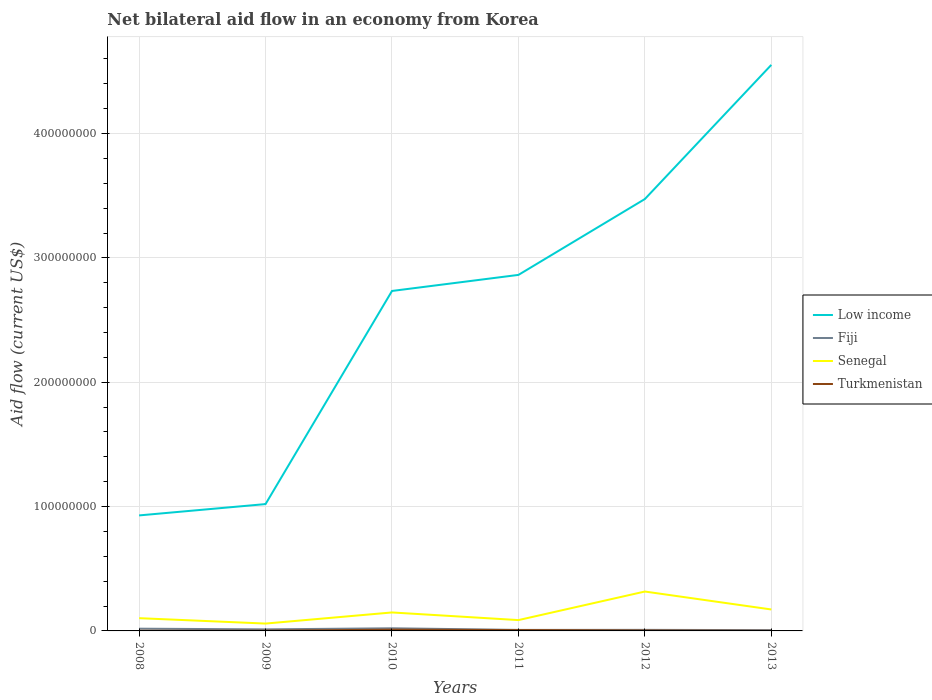How many different coloured lines are there?
Ensure brevity in your answer.  4. Is the number of lines equal to the number of legend labels?
Your answer should be very brief. Yes. Across all years, what is the maximum net bilateral aid flow in Senegal?
Ensure brevity in your answer.  5.92e+06. In which year was the net bilateral aid flow in Turkmenistan maximum?
Ensure brevity in your answer.  2008. What is the total net bilateral aid flow in Senegal in the graph?
Ensure brevity in your answer.  -2.79e+06. What is the difference between the highest and the second highest net bilateral aid flow in Fiji?
Give a very brief answer. 1.48e+06. How many lines are there?
Your response must be concise. 4. Are the values on the major ticks of Y-axis written in scientific E-notation?
Make the answer very short. No. Does the graph contain any zero values?
Make the answer very short. No. Does the graph contain grids?
Your answer should be compact. Yes. How are the legend labels stacked?
Provide a short and direct response. Vertical. What is the title of the graph?
Offer a very short reply. Net bilateral aid flow in an economy from Korea. What is the label or title of the Y-axis?
Offer a terse response. Aid flow (current US$). What is the Aid flow (current US$) in Low income in 2008?
Give a very brief answer. 9.29e+07. What is the Aid flow (current US$) of Fiji in 2008?
Keep it short and to the point. 1.80e+06. What is the Aid flow (current US$) of Senegal in 2008?
Your response must be concise. 1.02e+07. What is the Aid flow (current US$) of Low income in 2009?
Make the answer very short. 1.02e+08. What is the Aid flow (current US$) in Fiji in 2009?
Your answer should be very brief. 1.25e+06. What is the Aid flow (current US$) of Senegal in 2009?
Keep it short and to the point. 5.92e+06. What is the Aid flow (current US$) in Low income in 2010?
Your answer should be compact. 2.73e+08. What is the Aid flow (current US$) of Fiji in 2010?
Your response must be concise. 2.12e+06. What is the Aid flow (current US$) in Senegal in 2010?
Make the answer very short. 1.48e+07. What is the Aid flow (current US$) of Turkmenistan in 2010?
Provide a short and direct response. 1.01e+06. What is the Aid flow (current US$) in Low income in 2011?
Make the answer very short. 2.86e+08. What is the Aid flow (current US$) of Fiji in 2011?
Make the answer very short. 8.20e+05. What is the Aid flow (current US$) in Senegal in 2011?
Offer a terse response. 8.71e+06. What is the Aid flow (current US$) of Turkmenistan in 2011?
Offer a very short reply. 6.90e+05. What is the Aid flow (current US$) of Low income in 2012?
Ensure brevity in your answer.  3.47e+08. What is the Aid flow (current US$) of Fiji in 2012?
Offer a terse response. 8.60e+05. What is the Aid flow (current US$) of Senegal in 2012?
Provide a succinct answer. 3.17e+07. What is the Aid flow (current US$) of Low income in 2013?
Provide a succinct answer. 4.55e+08. What is the Aid flow (current US$) in Fiji in 2013?
Give a very brief answer. 6.40e+05. What is the Aid flow (current US$) of Senegal in 2013?
Give a very brief answer. 1.72e+07. Across all years, what is the maximum Aid flow (current US$) in Low income?
Provide a succinct answer. 4.55e+08. Across all years, what is the maximum Aid flow (current US$) in Fiji?
Offer a terse response. 2.12e+06. Across all years, what is the maximum Aid flow (current US$) in Senegal?
Offer a terse response. 3.17e+07. Across all years, what is the maximum Aid flow (current US$) of Turkmenistan?
Give a very brief answer. 1.01e+06. Across all years, what is the minimum Aid flow (current US$) of Low income?
Give a very brief answer. 9.29e+07. Across all years, what is the minimum Aid flow (current US$) in Fiji?
Provide a short and direct response. 6.40e+05. Across all years, what is the minimum Aid flow (current US$) of Senegal?
Offer a very short reply. 5.92e+06. What is the total Aid flow (current US$) in Low income in the graph?
Offer a terse response. 1.56e+09. What is the total Aid flow (current US$) in Fiji in the graph?
Provide a short and direct response. 7.49e+06. What is the total Aid flow (current US$) in Senegal in the graph?
Ensure brevity in your answer.  8.87e+07. What is the total Aid flow (current US$) of Turkmenistan in the graph?
Keep it short and to the point. 2.41e+06. What is the difference between the Aid flow (current US$) of Low income in 2008 and that in 2009?
Keep it short and to the point. -9.11e+06. What is the difference between the Aid flow (current US$) in Senegal in 2008 and that in 2009?
Keep it short and to the point. 4.33e+06. What is the difference between the Aid flow (current US$) of Turkmenistan in 2008 and that in 2009?
Make the answer very short. -6.00e+04. What is the difference between the Aid flow (current US$) in Low income in 2008 and that in 2010?
Ensure brevity in your answer.  -1.81e+08. What is the difference between the Aid flow (current US$) of Fiji in 2008 and that in 2010?
Offer a very short reply. -3.20e+05. What is the difference between the Aid flow (current US$) of Senegal in 2008 and that in 2010?
Provide a succinct answer. -4.60e+06. What is the difference between the Aid flow (current US$) in Turkmenistan in 2008 and that in 2010?
Offer a terse response. -9.00e+05. What is the difference between the Aid flow (current US$) of Low income in 2008 and that in 2011?
Give a very brief answer. -1.93e+08. What is the difference between the Aid flow (current US$) of Fiji in 2008 and that in 2011?
Offer a very short reply. 9.80e+05. What is the difference between the Aid flow (current US$) in Senegal in 2008 and that in 2011?
Provide a short and direct response. 1.54e+06. What is the difference between the Aid flow (current US$) in Turkmenistan in 2008 and that in 2011?
Offer a very short reply. -5.80e+05. What is the difference between the Aid flow (current US$) in Low income in 2008 and that in 2012?
Offer a very short reply. -2.54e+08. What is the difference between the Aid flow (current US$) of Fiji in 2008 and that in 2012?
Make the answer very short. 9.40e+05. What is the difference between the Aid flow (current US$) of Senegal in 2008 and that in 2012?
Provide a succinct answer. -2.14e+07. What is the difference between the Aid flow (current US$) of Turkmenistan in 2008 and that in 2012?
Your response must be concise. -2.10e+05. What is the difference between the Aid flow (current US$) in Low income in 2008 and that in 2013?
Your response must be concise. -3.62e+08. What is the difference between the Aid flow (current US$) in Fiji in 2008 and that in 2013?
Your answer should be very brief. 1.16e+06. What is the difference between the Aid flow (current US$) in Senegal in 2008 and that in 2013?
Your answer should be very brief. -7.00e+06. What is the difference between the Aid flow (current US$) in Turkmenistan in 2008 and that in 2013?
Offer a terse response. 0. What is the difference between the Aid flow (current US$) of Low income in 2009 and that in 2010?
Give a very brief answer. -1.71e+08. What is the difference between the Aid flow (current US$) in Fiji in 2009 and that in 2010?
Provide a succinct answer. -8.70e+05. What is the difference between the Aid flow (current US$) in Senegal in 2009 and that in 2010?
Provide a succinct answer. -8.93e+06. What is the difference between the Aid flow (current US$) of Turkmenistan in 2009 and that in 2010?
Your answer should be very brief. -8.40e+05. What is the difference between the Aid flow (current US$) of Low income in 2009 and that in 2011?
Offer a very short reply. -1.84e+08. What is the difference between the Aid flow (current US$) of Fiji in 2009 and that in 2011?
Give a very brief answer. 4.30e+05. What is the difference between the Aid flow (current US$) of Senegal in 2009 and that in 2011?
Make the answer very short. -2.79e+06. What is the difference between the Aid flow (current US$) of Turkmenistan in 2009 and that in 2011?
Give a very brief answer. -5.20e+05. What is the difference between the Aid flow (current US$) in Low income in 2009 and that in 2012?
Offer a very short reply. -2.45e+08. What is the difference between the Aid flow (current US$) of Senegal in 2009 and that in 2012?
Your answer should be compact. -2.58e+07. What is the difference between the Aid flow (current US$) of Low income in 2009 and that in 2013?
Your answer should be very brief. -3.53e+08. What is the difference between the Aid flow (current US$) in Fiji in 2009 and that in 2013?
Provide a succinct answer. 6.10e+05. What is the difference between the Aid flow (current US$) of Senegal in 2009 and that in 2013?
Your answer should be very brief. -1.13e+07. What is the difference between the Aid flow (current US$) of Turkmenistan in 2009 and that in 2013?
Give a very brief answer. 6.00e+04. What is the difference between the Aid flow (current US$) in Low income in 2010 and that in 2011?
Your answer should be very brief. -1.29e+07. What is the difference between the Aid flow (current US$) of Fiji in 2010 and that in 2011?
Your answer should be compact. 1.30e+06. What is the difference between the Aid flow (current US$) in Senegal in 2010 and that in 2011?
Your response must be concise. 6.14e+06. What is the difference between the Aid flow (current US$) of Turkmenistan in 2010 and that in 2011?
Make the answer very short. 3.20e+05. What is the difference between the Aid flow (current US$) in Low income in 2010 and that in 2012?
Offer a very short reply. -7.39e+07. What is the difference between the Aid flow (current US$) of Fiji in 2010 and that in 2012?
Provide a short and direct response. 1.26e+06. What is the difference between the Aid flow (current US$) in Senegal in 2010 and that in 2012?
Make the answer very short. -1.68e+07. What is the difference between the Aid flow (current US$) in Turkmenistan in 2010 and that in 2012?
Keep it short and to the point. 6.90e+05. What is the difference between the Aid flow (current US$) in Low income in 2010 and that in 2013?
Keep it short and to the point. -1.82e+08. What is the difference between the Aid flow (current US$) of Fiji in 2010 and that in 2013?
Keep it short and to the point. 1.48e+06. What is the difference between the Aid flow (current US$) in Senegal in 2010 and that in 2013?
Offer a very short reply. -2.40e+06. What is the difference between the Aid flow (current US$) in Low income in 2011 and that in 2012?
Make the answer very short. -6.10e+07. What is the difference between the Aid flow (current US$) of Senegal in 2011 and that in 2012?
Offer a very short reply. -2.30e+07. What is the difference between the Aid flow (current US$) of Turkmenistan in 2011 and that in 2012?
Your answer should be compact. 3.70e+05. What is the difference between the Aid flow (current US$) of Low income in 2011 and that in 2013?
Offer a very short reply. -1.69e+08. What is the difference between the Aid flow (current US$) in Fiji in 2011 and that in 2013?
Provide a succinct answer. 1.80e+05. What is the difference between the Aid flow (current US$) in Senegal in 2011 and that in 2013?
Your answer should be very brief. -8.54e+06. What is the difference between the Aid flow (current US$) in Turkmenistan in 2011 and that in 2013?
Offer a terse response. 5.80e+05. What is the difference between the Aid flow (current US$) of Low income in 2012 and that in 2013?
Keep it short and to the point. -1.08e+08. What is the difference between the Aid flow (current US$) in Fiji in 2012 and that in 2013?
Ensure brevity in your answer.  2.20e+05. What is the difference between the Aid flow (current US$) in Senegal in 2012 and that in 2013?
Offer a very short reply. 1.44e+07. What is the difference between the Aid flow (current US$) of Turkmenistan in 2012 and that in 2013?
Make the answer very short. 2.10e+05. What is the difference between the Aid flow (current US$) of Low income in 2008 and the Aid flow (current US$) of Fiji in 2009?
Provide a short and direct response. 9.16e+07. What is the difference between the Aid flow (current US$) in Low income in 2008 and the Aid flow (current US$) in Senegal in 2009?
Offer a very short reply. 8.70e+07. What is the difference between the Aid flow (current US$) of Low income in 2008 and the Aid flow (current US$) of Turkmenistan in 2009?
Offer a very short reply. 9.27e+07. What is the difference between the Aid flow (current US$) of Fiji in 2008 and the Aid flow (current US$) of Senegal in 2009?
Keep it short and to the point. -4.12e+06. What is the difference between the Aid flow (current US$) of Fiji in 2008 and the Aid flow (current US$) of Turkmenistan in 2009?
Your answer should be very brief. 1.63e+06. What is the difference between the Aid flow (current US$) in Senegal in 2008 and the Aid flow (current US$) in Turkmenistan in 2009?
Your response must be concise. 1.01e+07. What is the difference between the Aid flow (current US$) of Low income in 2008 and the Aid flow (current US$) of Fiji in 2010?
Provide a short and direct response. 9.08e+07. What is the difference between the Aid flow (current US$) of Low income in 2008 and the Aid flow (current US$) of Senegal in 2010?
Your response must be concise. 7.80e+07. What is the difference between the Aid flow (current US$) of Low income in 2008 and the Aid flow (current US$) of Turkmenistan in 2010?
Provide a succinct answer. 9.19e+07. What is the difference between the Aid flow (current US$) in Fiji in 2008 and the Aid flow (current US$) in Senegal in 2010?
Your response must be concise. -1.30e+07. What is the difference between the Aid flow (current US$) of Fiji in 2008 and the Aid flow (current US$) of Turkmenistan in 2010?
Keep it short and to the point. 7.90e+05. What is the difference between the Aid flow (current US$) in Senegal in 2008 and the Aid flow (current US$) in Turkmenistan in 2010?
Give a very brief answer. 9.24e+06. What is the difference between the Aid flow (current US$) in Low income in 2008 and the Aid flow (current US$) in Fiji in 2011?
Offer a very short reply. 9.21e+07. What is the difference between the Aid flow (current US$) in Low income in 2008 and the Aid flow (current US$) in Senegal in 2011?
Give a very brief answer. 8.42e+07. What is the difference between the Aid flow (current US$) in Low income in 2008 and the Aid flow (current US$) in Turkmenistan in 2011?
Provide a short and direct response. 9.22e+07. What is the difference between the Aid flow (current US$) in Fiji in 2008 and the Aid flow (current US$) in Senegal in 2011?
Your answer should be very brief. -6.91e+06. What is the difference between the Aid flow (current US$) of Fiji in 2008 and the Aid flow (current US$) of Turkmenistan in 2011?
Give a very brief answer. 1.11e+06. What is the difference between the Aid flow (current US$) in Senegal in 2008 and the Aid flow (current US$) in Turkmenistan in 2011?
Keep it short and to the point. 9.56e+06. What is the difference between the Aid flow (current US$) in Low income in 2008 and the Aid flow (current US$) in Fiji in 2012?
Provide a succinct answer. 9.20e+07. What is the difference between the Aid flow (current US$) of Low income in 2008 and the Aid flow (current US$) of Senegal in 2012?
Your answer should be very brief. 6.12e+07. What is the difference between the Aid flow (current US$) in Low income in 2008 and the Aid flow (current US$) in Turkmenistan in 2012?
Offer a very short reply. 9.26e+07. What is the difference between the Aid flow (current US$) of Fiji in 2008 and the Aid flow (current US$) of Senegal in 2012?
Your answer should be compact. -2.99e+07. What is the difference between the Aid flow (current US$) in Fiji in 2008 and the Aid flow (current US$) in Turkmenistan in 2012?
Give a very brief answer. 1.48e+06. What is the difference between the Aid flow (current US$) in Senegal in 2008 and the Aid flow (current US$) in Turkmenistan in 2012?
Ensure brevity in your answer.  9.93e+06. What is the difference between the Aid flow (current US$) of Low income in 2008 and the Aid flow (current US$) of Fiji in 2013?
Make the answer very short. 9.23e+07. What is the difference between the Aid flow (current US$) of Low income in 2008 and the Aid flow (current US$) of Senegal in 2013?
Keep it short and to the point. 7.56e+07. What is the difference between the Aid flow (current US$) of Low income in 2008 and the Aid flow (current US$) of Turkmenistan in 2013?
Your answer should be very brief. 9.28e+07. What is the difference between the Aid flow (current US$) in Fiji in 2008 and the Aid flow (current US$) in Senegal in 2013?
Offer a very short reply. -1.54e+07. What is the difference between the Aid flow (current US$) of Fiji in 2008 and the Aid flow (current US$) of Turkmenistan in 2013?
Provide a succinct answer. 1.69e+06. What is the difference between the Aid flow (current US$) of Senegal in 2008 and the Aid flow (current US$) of Turkmenistan in 2013?
Provide a succinct answer. 1.01e+07. What is the difference between the Aid flow (current US$) of Low income in 2009 and the Aid flow (current US$) of Fiji in 2010?
Ensure brevity in your answer.  9.99e+07. What is the difference between the Aid flow (current US$) of Low income in 2009 and the Aid flow (current US$) of Senegal in 2010?
Provide a succinct answer. 8.72e+07. What is the difference between the Aid flow (current US$) in Low income in 2009 and the Aid flow (current US$) in Turkmenistan in 2010?
Ensure brevity in your answer.  1.01e+08. What is the difference between the Aid flow (current US$) of Fiji in 2009 and the Aid flow (current US$) of Senegal in 2010?
Your response must be concise. -1.36e+07. What is the difference between the Aid flow (current US$) in Senegal in 2009 and the Aid flow (current US$) in Turkmenistan in 2010?
Your response must be concise. 4.91e+06. What is the difference between the Aid flow (current US$) in Low income in 2009 and the Aid flow (current US$) in Fiji in 2011?
Provide a short and direct response. 1.01e+08. What is the difference between the Aid flow (current US$) of Low income in 2009 and the Aid flow (current US$) of Senegal in 2011?
Offer a terse response. 9.33e+07. What is the difference between the Aid flow (current US$) in Low income in 2009 and the Aid flow (current US$) in Turkmenistan in 2011?
Keep it short and to the point. 1.01e+08. What is the difference between the Aid flow (current US$) of Fiji in 2009 and the Aid flow (current US$) of Senegal in 2011?
Ensure brevity in your answer.  -7.46e+06. What is the difference between the Aid flow (current US$) of Fiji in 2009 and the Aid flow (current US$) of Turkmenistan in 2011?
Your response must be concise. 5.60e+05. What is the difference between the Aid flow (current US$) of Senegal in 2009 and the Aid flow (current US$) of Turkmenistan in 2011?
Your answer should be very brief. 5.23e+06. What is the difference between the Aid flow (current US$) of Low income in 2009 and the Aid flow (current US$) of Fiji in 2012?
Offer a terse response. 1.01e+08. What is the difference between the Aid flow (current US$) in Low income in 2009 and the Aid flow (current US$) in Senegal in 2012?
Make the answer very short. 7.03e+07. What is the difference between the Aid flow (current US$) of Low income in 2009 and the Aid flow (current US$) of Turkmenistan in 2012?
Offer a very short reply. 1.02e+08. What is the difference between the Aid flow (current US$) of Fiji in 2009 and the Aid flow (current US$) of Senegal in 2012?
Offer a very short reply. -3.04e+07. What is the difference between the Aid flow (current US$) in Fiji in 2009 and the Aid flow (current US$) in Turkmenistan in 2012?
Your answer should be compact. 9.30e+05. What is the difference between the Aid flow (current US$) in Senegal in 2009 and the Aid flow (current US$) in Turkmenistan in 2012?
Keep it short and to the point. 5.60e+06. What is the difference between the Aid flow (current US$) of Low income in 2009 and the Aid flow (current US$) of Fiji in 2013?
Provide a short and direct response. 1.01e+08. What is the difference between the Aid flow (current US$) in Low income in 2009 and the Aid flow (current US$) in Senegal in 2013?
Your answer should be very brief. 8.48e+07. What is the difference between the Aid flow (current US$) in Low income in 2009 and the Aid flow (current US$) in Turkmenistan in 2013?
Make the answer very short. 1.02e+08. What is the difference between the Aid flow (current US$) in Fiji in 2009 and the Aid flow (current US$) in Senegal in 2013?
Provide a succinct answer. -1.60e+07. What is the difference between the Aid flow (current US$) of Fiji in 2009 and the Aid flow (current US$) of Turkmenistan in 2013?
Your answer should be very brief. 1.14e+06. What is the difference between the Aid flow (current US$) in Senegal in 2009 and the Aid flow (current US$) in Turkmenistan in 2013?
Offer a terse response. 5.81e+06. What is the difference between the Aid flow (current US$) of Low income in 2010 and the Aid flow (current US$) of Fiji in 2011?
Your answer should be compact. 2.73e+08. What is the difference between the Aid flow (current US$) of Low income in 2010 and the Aid flow (current US$) of Senegal in 2011?
Your response must be concise. 2.65e+08. What is the difference between the Aid flow (current US$) in Low income in 2010 and the Aid flow (current US$) in Turkmenistan in 2011?
Give a very brief answer. 2.73e+08. What is the difference between the Aid flow (current US$) of Fiji in 2010 and the Aid flow (current US$) of Senegal in 2011?
Offer a very short reply. -6.59e+06. What is the difference between the Aid flow (current US$) in Fiji in 2010 and the Aid flow (current US$) in Turkmenistan in 2011?
Provide a short and direct response. 1.43e+06. What is the difference between the Aid flow (current US$) of Senegal in 2010 and the Aid flow (current US$) of Turkmenistan in 2011?
Provide a succinct answer. 1.42e+07. What is the difference between the Aid flow (current US$) of Low income in 2010 and the Aid flow (current US$) of Fiji in 2012?
Give a very brief answer. 2.73e+08. What is the difference between the Aid flow (current US$) in Low income in 2010 and the Aid flow (current US$) in Senegal in 2012?
Offer a very short reply. 2.42e+08. What is the difference between the Aid flow (current US$) of Low income in 2010 and the Aid flow (current US$) of Turkmenistan in 2012?
Make the answer very short. 2.73e+08. What is the difference between the Aid flow (current US$) of Fiji in 2010 and the Aid flow (current US$) of Senegal in 2012?
Give a very brief answer. -2.96e+07. What is the difference between the Aid flow (current US$) of Fiji in 2010 and the Aid flow (current US$) of Turkmenistan in 2012?
Ensure brevity in your answer.  1.80e+06. What is the difference between the Aid flow (current US$) in Senegal in 2010 and the Aid flow (current US$) in Turkmenistan in 2012?
Keep it short and to the point. 1.45e+07. What is the difference between the Aid flow (current US$) of Low income in 2010 and the Aid flow (current US$) of Fiji in 2013?
Your response must be concise. 2.73e+08. What is the difference between the Aid flow (current US$) of Low income in 2010 and the Aid flow (current US$) of Senegal in 2013?
Your response must be concise. 2.56e+08. What is the difference between the Aid flow (current US$) in Low income in 2010 and the Aid flow (current US$) in Turkmenistan in 2013?
Provide a short and direct response. 2.73e+08. What is the difference between the Aid flow (current US$) of Fiji in 2010 and the Aid flow (current US$) of Senegal in 2013?
Give a very brief answer. -1.51e+07. What is the difference between the Aid flow (current US$) in Fiji in 2010 and the Aid flow (current US$) in Turkmenistan in 2013?
Offer a very short reply. 2.01e+06. What is the difference between the Aid flow (current US$) in Senegal in 2010 and the Aid flow (current US$) in Turkmenistan in 2013?
Offer a terse response. 1.47e+07. What is the difference between the Aid flow (current US$) in Low income in 2011 and the Aid flow (current US$) in Fiji in 2012?
Keep it short and to the point. 2.85e+08. What is the difference between the Aid flow (current US$) of Low income in 2011 and the Aid flow (current US$) of Senegal in 2012?
Offer a terse response. 2.55e+08. What is the difference between the Aid flow (current US$) of Low income in 2011 and the Aid flow (current US$) of Turkmenistan in 2012?
Provide a short and direct response. 2.86e+08. What is the difference between the Aid flow (current US$) in Fiji in 2011 and the Aid flow (current US$) in Senegal in 2012?
Your response must be concise. -3.09e+07. What is the difference between the Aid flow (current US$) of Fiji in 2011 and the Aid flow (current US$) of Turkmenistan in 2012?
Provide a succinct answer. 5.00e+05. What is the difference between the Aid flow (current US$) in Senegal in 2011 and the Aid flow (current US$) in Turkmenistan in 2012?
Your answer should be very brief. 8.39e+06. What is the difference between the Aid flow (current US$) of Low income in 2011 and the Aid flow (current US$) of Fiji in 2013?
Provide a succinct answer. 2.86e+08. What is the difference between the Aid flow (current US$) of Low income in 2011 and the Aid flow (current US$) of Senegal in 2013?
Your answer should be compact. 2.69e+08. What is the difference between the Aid flow (current US$) of Low income in 2011 and the Aid flow (current US$) of Turkmenistan in 2013?
Your response must be concise. 2.86e+08. What is the difference between the Aid flow (current US$) of Fiji in 2011 and the Aid flow (current US$) of Senegal in 2013?
Offer a terse response. -1.64e+07. What is the difference between the Aid flow (current US$) in Fiji in 2011 and the Aid flow (current US$) in Turkmenistan in 2013?
Provide a short and direct response. 7.10e+05. What is the difference between the Aid flow (current US$) in Senegal in 2011 and the Aid flow (current US$) in Turkmenistan in 2013?
Offer a very short reply. 8.60e+06. What is the difference between the Aid flow (current US$) of Low income in 2012 and the Aid flow (current US$) of Fiji in 2013?
Offer a very short reply. 3.47e+08. What is the difference between the Aid flow (current US$) in Low income in 2012 and the Aid flow (current US$) in Senegal in 2013?
Give a very brief answer. 3.30e+08. What is the difference between the Aid flow (current US$) in Low income in 2012 and the Aid flow (current US$) in Turkmenistan in 2013?
Make the answer very short. 3.47e+08. What is the difference between the Aid flow (current US$) of Fiji in 2012 and the Aid flow (current US$) of Senegal in 2013?
Keep it short and to the point. -1.64e+07. What is the difference between the Aid flow (current US$) of Fiji in 2012 and the Aid flow (current US$) of Turkmenistan in 2013?
Make the answer very short. 7.50e+05. What is the difference between the Aid flow (current US$) of Senegal in 2012 and the Aid flow (current US$) of Turkmenistan in 2013?
Offer a terse response. 3.16e+07. What is the average Aid flow (current US$) of Low income per year?
Offer a very short reply. 2.60e+08. What is the average Aid flow (current US$) of Fiji per year?
Offer a very short reply. 1.25e+06. What is the average Aid flow (current US$) of Senegal per year?
Offer a very short reply. 1.48e+07. What is the average Aid flow (current US$) in Turkmenistan per year?
Keep it short and to the point. 4.02e+05. In the year 2008, what is the difference between the Aid flow (current US$) in Low income and Aid flow (current US$) in Fiji?
Provide a short and direct response. 9.11e+07. In the year 2008, what is the difference between the Aid flow (current US$) in Low income and Aid flow (current US$) in Senegal?
Your response must be concise. 8.26e+07. In the year 2008, what is the difference between the Aid flow (current US$) in Low income and Aid flow (current US$) in Turkmenistan?
Provide a succinct answer. 9.28e+07. In the year 2008, what is the difference between the Aid flow (current US$) in Fiji and Aid flow (current US$) in Senegal?
Make the answer very short. -8.45e+06. In the year 2008, what is the difference between the Aid flow (current US$) in Fiji and Aid flow (current US$) in Turkmenistan?
Ensure brevity in your answer.  1.69e+06. In the year 2008, what is the difference between the Aid flow (current US$) of Senegal and Aid flow (current US$) of Turkmenistan?
Your answer should be very brief. 1.01e+07. In the year 2009, what is the difference between the Aid flow (current US$) of Low income and Aid flow (current US$) of Fiji?
Keep it short and to the point. 1.01e+08. In the year 2009, what is the difference between the Aid flow (current US$) in Low income and Aid flow (current US$) in Senegal?
Ensure brevity in your answer.  9.61e+07. In the year 2009, what is the difference between the Aid flow (current US$) of Low income and Aid flow (current US$) of Turkmenistan?
Your answer should be compact. 1.02e+08. In the year 2009, what is the difference between the Aid flow (current US$) of Fiji and Aid flow (current US$) of Senegal?
Offer a very short reply. -4.67e+06. In the year 2009, what is the difference between the Aid flow (current US$) of Fiji and Aid flow (current US$) of Turkmenistan?
Your answer should be very brief. 1.08e+06. In the year 2009, what is the difference between the Aid flow (current US$) of Senegal and Aid flow (current US$) of Turkmenistan?
Provide a short and direct response. 5.75e+06. In the year 2010, what is the difference between the Aid flow (current US$) of Low income and Aid flow (current US$) of Fiji?
Your response must be concise. 2.71e+08. In the year 2010, what is the difference between the Aid flow (current US$) of Low income and Aid flow (current US$) of Senegal?
Your answer should be compact. 2.59e+08. In the year 2010, what is the difference between the Aid flow (current US$) in Low income and Aid flow (current US$) in Turkmenistan?
Give a very brief answer. 2.72e+08. In the year 2010, what is the difference between the Aid flow (current US$) of Fiji and Aid flow (current US$) of Senegal?
Give a very brief answer. -1.27e+07. In the year 2010, what is the difference between the Aid flow (current US$) of Fiji and Aid flow (current US$) of Turkmenistan?
Keep it short and to the point. 1.11e+06. In the year 2010, what is the difference between the Aid flow (current US$) in Senegal and Aid flow (current US$) in Turkmenistan?
Your answer should be compact. 1.38e+07. In the year 2011, what is the difference between the Aid flow (current US$) in Low income and Aid flow (current US$) in Fiji?
Give a very brief answer. 2.86e+08. In the year 2011, what is the difference between the Aid flow (current US$) in Low income and Aid flow (current US$) in Senegal?
Your response must be concise. 2.78e+08. In the year 2011, what is the difference between the Aid flow (current US$) in Low income and Aid flow (current US$) in Turkmenistan?
Keep it short and to the point. 2.86e+08. In the year 2011, what is the difference between the Aid flow (current US$) of Fiji and Aid flow (current US$) of Senegal?
Provide a succinct answer. -7.89e+06. In the year 2011, what is the difference between the Aid flow (current US$) in Senegal and Aid flow (current US$) in Turkmenistan?
Keep it short and to the point. 8.02e+06. In the year 2012, what is the difference between the Aid flow (current US$) in Low income and Aid flow (current US$) in Fiji?
Make the answer very short. 3.46e+08. In the year 2012, what is the difference between the Aid flow (current US$) of Low income and Aid flow (current US$) of Senegal?
Your answer should be compact. 3.16e+08. In the year 2012, what is the difference between the Aid flow (current US$) in Low income and Aid flow (current US$) in Turkmenistan?
Give a very brief answer. 3.47e+08. In the year 2012, what is the difference between the Aid flow (current US$) of Fiji and Aid flow (current US$) of Senegal?
Your answer should be compact. -3.08e+07. In the year 2012, what is the difference between the Aid flow (current US$) in Fiji and Aid flow (current US$) in Turkmenistan?
Offer a very short reply. 5.40e+05. In the year 2012, what is the difference between the Aid flow (current US$) in Senegal and Aid flow (current US$) in Turkmenistan?
Your response must be concise. 3.14e+07. In the year 2013, what is the difference between the Aid flow (current US$) of Low income and Aid flow (current US$) of Fiji?
Give a very brief answer. 4.55e+08. In the year 2013, what is the difference between the Aid flow (current US$) of Low income and Aid flow (current US$) of Senegal?
Make the answer very short. 4.38e+08. In the year 2013, what is the difference between the Aid flow (current US$) of Low income and Aid flow (current US$) of Turkmenistan?
Keep it short and to the point. 4.55e+08. In the year 2013, what is the difference between the Aid flow (current US$) in Fiji and Aid flow (current US$) in Senegal?
Provide a succinct answer. -1.66e+07. In the year 2013, what is the difference between the Aid flow (current US$) in Fiji and Aid flow (current US$) in Turkmenistan?
Give a very brief answer. 5.30e+05. In the year 2013, what is the difference between the Aid flow (current US$) of Senegal and Aid flow (current US$) of Turkmenistan?
Offer a terse response. 1.71e+07. What is the ratio of the Aid flow (current US$) in Low income in 2008 to that in 2009?
Your answer should be very brief. 0.91. What is the ratio of the Aid flow (current US$) of Fiji in 2008 to that in 2009?
Offer a very short reply. 1.44. What is the ratio of the Aid flow (current US$) of Senegal in 2008 to that in 2009?
Give a very brief answer. 1.73. What is the ratio of the Aid flow (current US$) of Turkmenistan in 2008 to that in 2009?
Keep it short and to the point. 0.65. What is the ratio of the Aid flow (current US$) of Low income in 2008 to that in 2010?
Provide a short and direct response. 0.34. What is the ratio of the Aid flow (current US$) of Fiji in 2008 to that in 2010?
Your response must be concise. 0.85. What is the ratio of the Aid flow (current US$) of Senegal in 2008 to that in 2010?
Your answer should be very brief. 0.69. What is the ratio of the Aid flow (current US$) of Turkmenistan in 2008 to that in 2010?
Offer a very short reply. 0.11. What is the ratio of the Aid flow (current US$) of Low income in 2008 to that in 2011?
Your answer should be compact. 0.32. What is the ratio of the Aid flow (current US$) of Fiji in 2008 to that in 2011?
Your response must be concise. 2.2. What is the ratio of the Aid flow (current US$) in Senegal in 2008 to that in 2011?
Your response must be concise. 1.18. What is the ratio of the Aid flow (current US$) of Turkmenistan in 2008 to that in 2011?
Ensure brevity in your answer.  0.16. What is the ratio of the Aid flow (current US$) in Low income in 2008 to that in 2012?
Make the answer very short. 0.27. What is the ratio of the Aid flow (current US$) in Fiji in 2008 to that in 2012?
Ensure brevity in your answer.  2.09. What is the ratio of the Aid flow (current US$) in Senegal in 2008 to that in 2012?
Ensure brevity in your answer.  0.32. What is the ratio of the Aid flow (current US$) of Turkmenistan in 2008 to that in 2012?
Offer a very short reply. 0.34. What is the ratio of the Aid flow (current US$) in Low income in 2008 to that in 2013?
Offer a terse response. 0.2. What is the ratio of the Aid flow (current US$) of Fiji in 2008 to that in 2013?
Offer a terse response. 2.81. What is the ratio of the Aid flow (current US$) of Senegal in 2008 to that in 2013?
Offer a very short reply. 0.59. What is the ratio of the Aid flow (current US$) of Low income in 2009 to that in 2010?
Your answer should be compact. 0.37. What is the ratio of the Aid flow (current US$) in Fiji in 2009 to that in 2010?
Your response must be concise. 0.59. What is the ratio of the Aid flow (current US$) in Senegal in 2009 to that in 2010?
Keep it short and to the point. 0.4. What is the ratio of the Aid flow (current US$) of Turkmenistan in 2009 to that in 2010?
Offer a terse response. 0.17. What is the ratio of the Aid flow (current US$) in Low income in 2009 to that in 2011?
Make the answer very short. 0.36. What is the ratio of the Aid flow (current US$) in Fiji in 2009 to that in 2011?
Your answer should be very brief. 1.52. What is the ratio of the Aid flow (current US$) in Senegal in 2009 to that in 2011?
Make the answer very short. 0.68. What is the ratio of the Aid flow (current US$) in Turkmenistan in 2009 to that in 2011?
Offer a very short reply. 0.25. What is the ratio of the Aid flow (current US$) of Low income in 2009 to that in 2012?
Give a very brief answer. 0.29. What is the ratio of the Aid flow (current US$) in Fiji in 2009 to that in 2012?
Offer a terse response. 1.45. What is the ratio of the Aid flow (current US$) in Senegal in 2009 to that in 2012?
Offer a terse response. 0.19. What is the ratio of the Aid flow (current US$) of Turkmenistan in 2009 to that in 2012?
Ensure brevity in your answer.  0.53. What is the ratio of the Aid flow (current US$) in Low income in 2009 to that in 2013?
Offer a very short reply. 0.22. What is the ratio of the Aid flow (current US$) of Fiji in 2009 to that in 2013?
Your answer should be very brief. 1.95. What is the ratio of the Aid flow (current US$) in Senegal in 2009 to that in 2013?
Give a very brief answer. 0.34. What is the ratio of the Aid flow (current US$) in Turkmenistan in 2009 to that in 2013?
Offer a terse response. 1.55. What is the ratio of the Aid flow (current US$) in Low income in 2010 to that in 2011?
Your answer should be compact. 0.95. What is the ratio of the Aid flow (current US$) in Fiji in 2010 to that in 2011?
Provide a succinct answer. 2.59. What is the ratio of the Aid flow (current US$) of Senegal in 2010 to that in 2011?
Your answer should be compact. 1.7. What is the ratio of the Aid flow (current US$) in Turkmenistan in 2010 to that in 2011?
Offer a very short reply. 1.46. What is the ratio of the Aid flow (current US$) in Low income in 2010 to that in 2012?
Your answer should be compact. 0.79. What is the ratio of the Aid flow (current US$) of Fiji in 2010 to that in 2012?
Keep it short and to the point. 2.47. What is the ratio of the Aid flow (current US$) of Senegal in 2010 to that in 2012?
Your answer should be compact. 0.47. What is the ratio of the Aid flow (current US$) in Turkmenistan in 2010 to that in 2012?
Ensure brevity in your answer.  3.16. What is the ratio of the Aid flow (current US$) in Low income in 2010 to that in 2013?
Your answer should be very brief. 0.6. What is the ratio of the Aid flow (current US$) of Fiji in 2010 to that in 2013?
Your response must be concise. 3.31. What is the ratio of the Aid flow (current US$) in Senegal in 2010 to that in 2013?
Provide a short and direct response. 0.86. What is the ratio of the Aid flow (current US$) in Turkmenistan in 2010 to that in 2013?
Your answer should be very brief. 9.18. What is the ratio of the Aid flow (current US$) in Low income in 2011 to that in 2012?
Give a very brief answer. 0.82. What is the ratio of the Aid flow (current US$) of Fiji in 2011 to that in 2012?
Keep it short and to the point. 0.95. What is the ratio of the Aid flow (current US$) in Senegal in 2011 to that in 2012?
Offer a terse response. 0.27. What is the ratio of the Aid flow (current US$) in Turkmenistan in 2011 to that in 2012?
Give a very brief answer. 2.16. What is the ratio of the Aid flow (current US$) in Low income in 2011 to that in 2013?
Give a very brief answer. 0.63. What is the ratio of the Aid flow (current US$) in Fiji in 2011 to that in 2013?
Ensure brevity in your answer.  1.28. What is the ratio of the Aid flow (current US$) in Senegal in 2011 to that in 2013?
Offer a very short reply. 0.5. What is the ratio of the Aid flow (current US$) in Turkmenistan in 2011 to that in 2013?
Offer a very short reply. 6.27. What is the ratio of the Aid flow (current US$) of Low income in 2012 to that in 2013?
Your answer should be compact. 0.76. What is the ratio of the Aid flow (current US$) of Fiji in 2012 to that in 2013?
Provide a short and direct response. 1.34. What is the ratio of the Aid flow (current US$) of Senegal in 2012 to that in 2013?
Your answer should be compact. 1.84. What is the ratio of the Aid flow (current US$) in Turkmenistan in 2012 to that in 2013?
Your response must be concise. 2.91. What is the difference between the highest and the second highest Aid flow (current US$) in Low income?
Ensure brevity in your answer.  1.08e+08. What is the difference between the highest and the second highest Aid flow (current US$) of Senegal?
Your answer should be compact. 1.44e+07. What is the difference between the highest and the second highest Aid flow (current US$) in Turkmenistan?
Provide a short and direct response. 3.20e+05. What is the difference between the highest and the lowest Aid flow (current US$) of Low income?
Offer a terse response. 3.62e+08. What is the difference between the highest and the lowest Aid flow (current US$) of Fiji?
Offer a very short reply. 1.48e+06. What is the difference between the highest and the lowest Aid flow (current US$) in Senegal?
Give a very brief answer. 2.58e+07. 